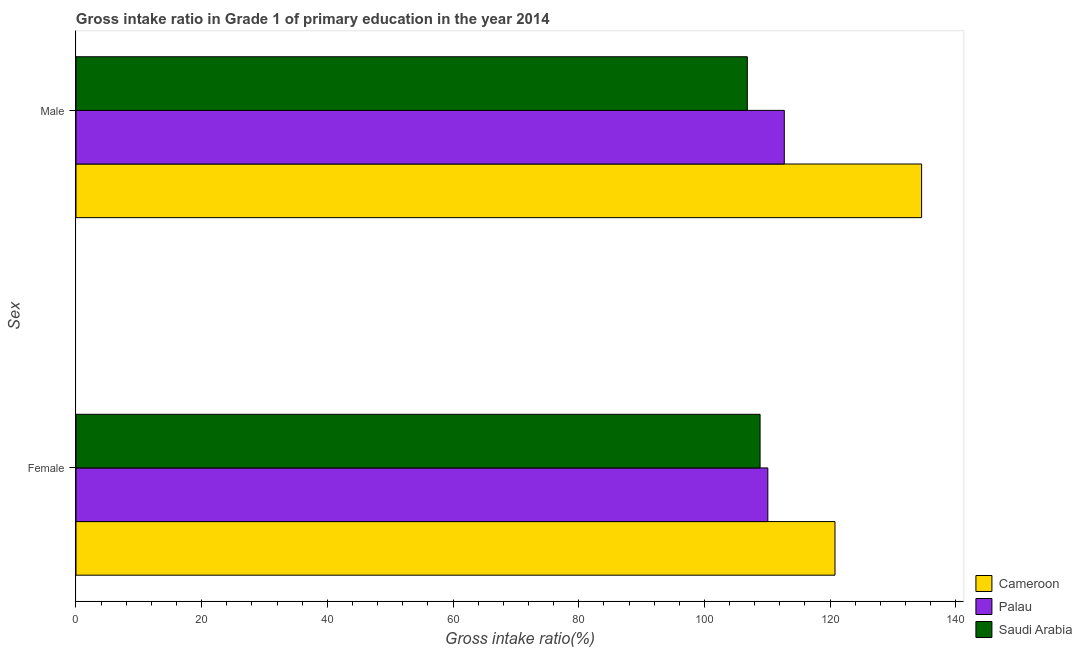How many different coloured bars are there?
Give a very brief answer. 3. Are the number of bars per tick equal to the number of legend labels?
Give a very brief answer. Yes. Are the number of bars on each tick of the Y-axis equal?
Provide a short and direct response. Yes. How many bars are there on the 1st tick from the top?
Offer a very short reply. 3. What is the label of the 2nd group of bars from the top?
Offer a terse response. Female. What is the gross intake ratio(female) in Saudi Arabia?
Keep it short and to the point. 108.86. Across all countries, what is the maximum gross intake ratio(male)?
Offer a terse response. 134.56. Across all countries, what is the minimum gross intake ratio(male)?
Ensure brevity in your answer.  106.83. In which country was the gross intake ratio(female) maximum?
Provide a succinct answer. Cameroon. In which country was the gross intake ratio(male) minimum?
Offer a very short reply. Saudi Arabia. What is the total gross intake ratio(male) in the graph?
Your answer should be very brief. 354.1. What is the difference between the gross intake ratio(female) in Cameroon and that in Saudi Arabia?
Ensure brevity in your answer.  11.92. What is the difference between the gross intake ratio(female) in Palau and the gross intake ratio(male) in Saudi Arabia?
Make the answer very short. 3.26. What is the average gross intake ratio(female) per country?
Give a very brief answer. 113.24. What is the difference between the gross intake ratio(male) and gross intake ratio(female) in Palau?
Provide a short and direct response. 2.62. In how many countries, is the gross intake ratio(female) greater than 92 %?
Provide a succinct answer. 3. What is the ratio of the gross intake ratio(female) in Palau to that in Cameroon?
Provide a succinct answer. 0.91. In how many countries, is the gross intake ratio(female) greater than the average gross intake ratio(female) taken over all countries?
Give a very brief answer. 1. What does the 3rd bar from the top in Male represents?
Your answer should be compact. Cameroon. What does the 3rd bar from the bottom in Female represents?
Your answer should be very brief. Saudi Arabia. How many bars are there?
Offer a very short reply. 6. Are all the bars in the graph horizontal?
Your response must be concise. Yes. Are the values on the major ticks of X-axis written in scientific E-notation?
Your answer should be compact. No. Does the graph contain any zero values?
Ensure brevity in your answer.  No. Where does the legend appear in the graph?
Provide a short and direct response. Bottom right. What is the title of the graph?
Offer a terse response. Gross intake ratio in Grade 1 of primary education in the year 2014. What is the label or title of the X-axis?
Offer a terse response. Gross intake ratio(%). What is the label or title of the Y-axis?
Your answer should be very brief. Sex. What is the Gross intake ratio(%) in Cameroon in Female?
Provide a short and direct response. 120.78. What is the Gross intake ratio(%) of Palau in Female?
Your answer should be compact. 110.09. What is the Gross intake ratio(%) of Saudi Arabia in Female?
Your answer should be very brief. 108.86. What is the Gross intake ratio(%) in Cameroon in Male?
Make the answer very short. 134.56. What is the Gross intake ratio(%) in Palau in Male?
Keep it short and to the point. 112.71. What is the Gross intake ratio(%) of Saudi Arabia in Male?
Provide a short and direct response. 106.83. Across all Sex, what is the maximum Gross intake ratio(%) in Cameroon?
Your response must be concise. 134.56. Across all Sex, what is the maximum Gross intake ratio(%) of Palau?
Keep it short and to the point. 112.71. Across all Sex, what is the maximum Gross intake ratio(%) in Saudi Arabia?
Your answer should be very brief. 108.86. Across all Sex, what is the minimum Gross intake ratio(%) of Cameroon?
Your response must be concise. 120.78. Across all Sex, what is the minimum Gross intake ratio(%) in Palau?
Keep it short and to the point. 110.09. Across all Sex, what is the minimum Gross intake ratio(%) of Saudi Arabia?
Give a very brief answer. 106.83. What is the total Gross intake ratio(%) in Cameroon in the graph?
Give a very brief answer. 255.34. What is the total Gross intake ratio(%) of Palau in the graph?
Provide a succinct answer. 222.8. What is the total Gross intake ratio(%) in Saudi Arabia in the graph?
Offer a very short reply. 215.69. What is the difference between the Gross intake ratio(%) in Cameroon in Female and that in Male?
Ensure brevity in your answer.  -13.78. What is the difference between the Gross intake ratio(%) in Palau in Female and that in Male?
Offer a very short reply. -2.62. What is the difference between the Gross intake ratio(%) of Saudi Arabia in Female and that in Male?
Ensure brevity in your answer.  2.03. What is the difference between the Gross intake ratio(%) of Cameroon in Female and the Gross intake ratio(%) of Palau in Male?
Make the answer very short. 8.07. What is the difference between the Gross intake ratio(%) in Cameroon in Female and the Gross intake ratio(%) in Saudi Arabia in Male?
Make the answer very short. 13.95. What is the difference between the Gross intake ratio(%) of Palau in Female and the Gross intake ratio(%) of Saudi Arabia in Male?
Provide a short and direct response. 3.26. What is the average Gross intake ratio(%) in Cameroon per Sex?
Your response must be concise. 127.67. What is the average Gross intake ratio(%) in Palau per Sex?
Make the answer very short. 111.4. What is the average Gross intake ratio(%) of Saudi Arabia per Sex?
Provide a succinct answer. 107.84. What is the difference between the Gross intake ratio(%) of Cameroon and Gross intake ratio(%) of Palau in Female?
Give a very brief answer. 10.69. What is the difference between the Gross intake ratio(%) in Cameroon and Gross intake ratio(%) in Saudi Arabia in Female?
Keep it short and to the point. 11.92. What is the difference between the Gross intake ratio(%) in Palau and Gross intake ratio(%) in Saudi Arabia in Female?
Your response must be concise. 1.23. What is the difference between the Gross intake ratio(%) in Cameroon and Gross intake ratio(%) in Palau in Male?
Provide a short and direct response. 21.85. What is the difference between the Gross intake ratio(%) of Cameroon and Gross intake ratio(%) of Saudi Arabia in Male?
Offer a terse response. 27.74. What is the difference between the Gross intake ratio(%) of Palau and Gross intake ratio(%) of Saudi Arabia in Male?
Your response must be concise. 5.88. What is the ratio of the Gross intake ratio(%) in Cameroon in Female to that in Male?
Make the answer very short. 0.9. What is the ratio of the Gross intake ratio(%) of Palau in Female to that in Male?
Provide a succinct answer. 0.98. What is the ratio of the Gross intake ratio(%) of Saudi Arabia in Female to that in Male?
Offer a very short reply. 1.02. What is the difference between the highest and the second highest Gross intake ratio(%) of Cameroon?
Provide a short and direct response. 13.78. What is the difference between the highest and the second highest Gross intake ratio(%) of Palau?
Your response must be concise. 2.62. What is the difference between the highest and the second highest Gross intake ratio(%) in Saudi Arabia?
Offer a very short reply. 2.03. What is the difference between the highest and the lowest Gross intake ratio(%) in Cameroon?
Make the answer very short. 13.78. What is the difference between the highest and the lowest Gross intake ratio(%) of Palau?
Your response must be concise. 2.62. What is the difference between the highest and the lowest Gross intake ratio(%) of Saudi Arabia?
Offer a very short reply. 2.03. 